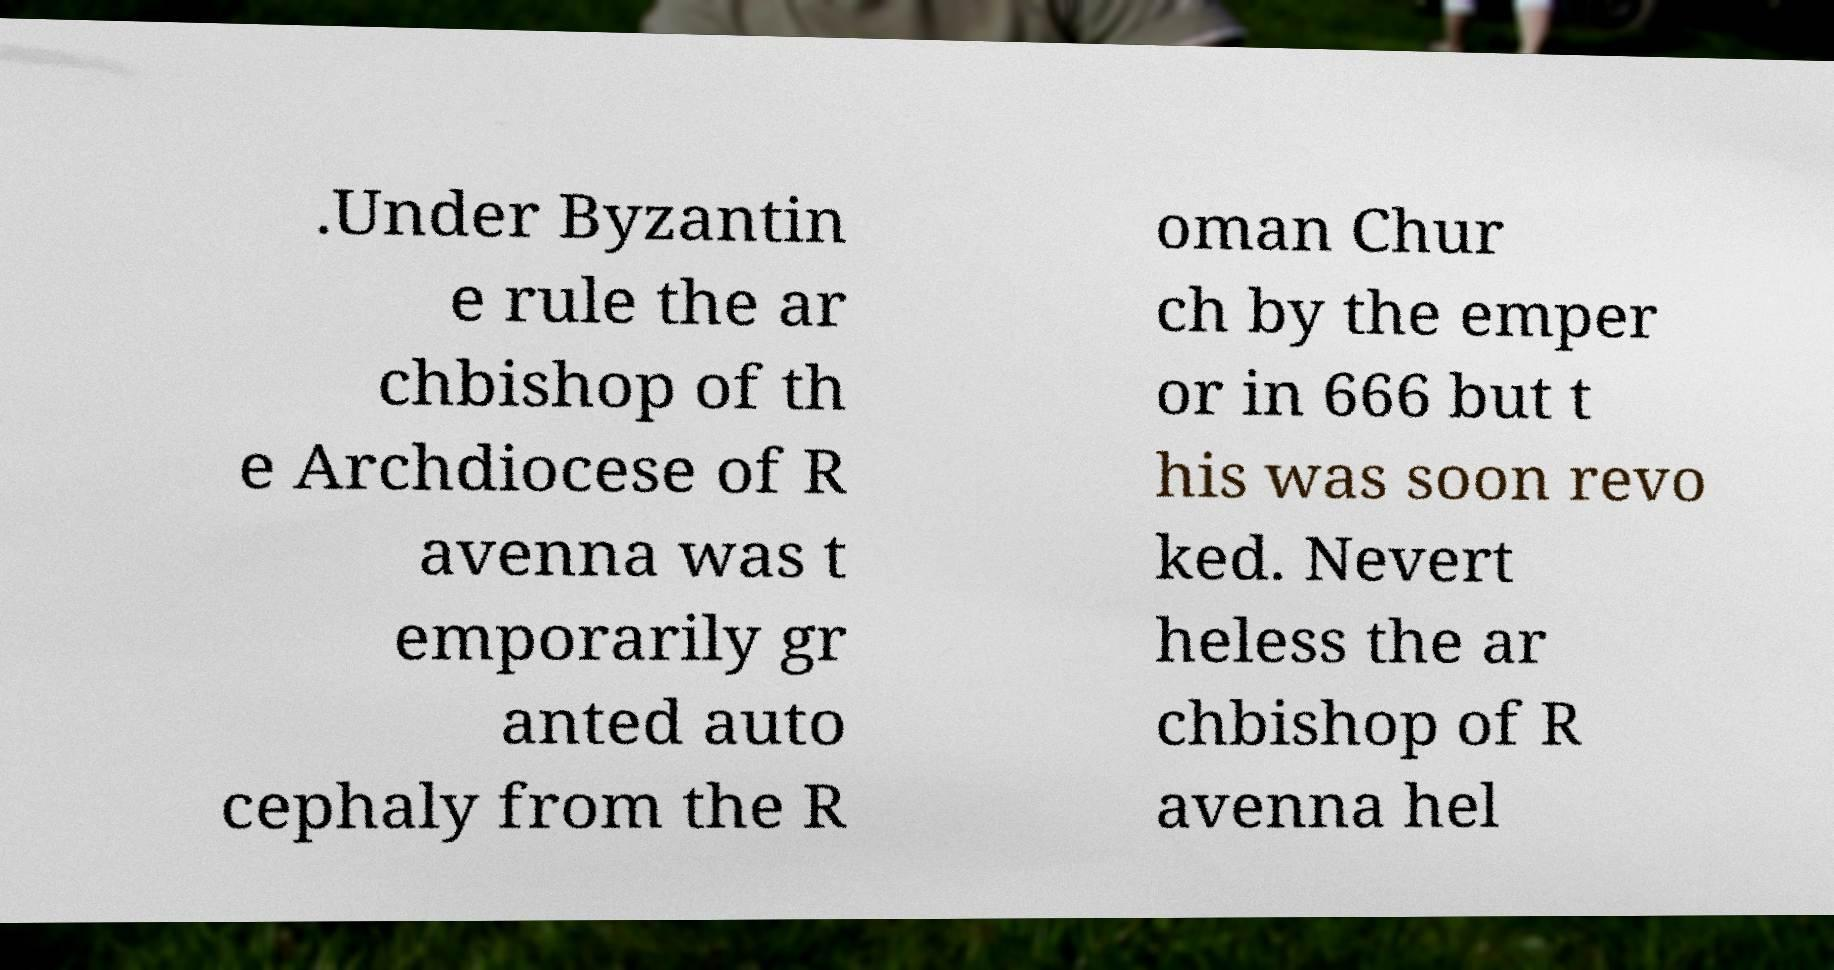For documentation purposes, I need the text within this image transcribed. Could you provide that? .Under Byzantin e rule the ar chbishop of th e Archdiocese of R avenna was t emporarily gr anted auto cephaly from the R oman Chur ch by the emper or in 666 but t his was soon revo ked. Nevert heless the ar chbishop of R avenna hel 